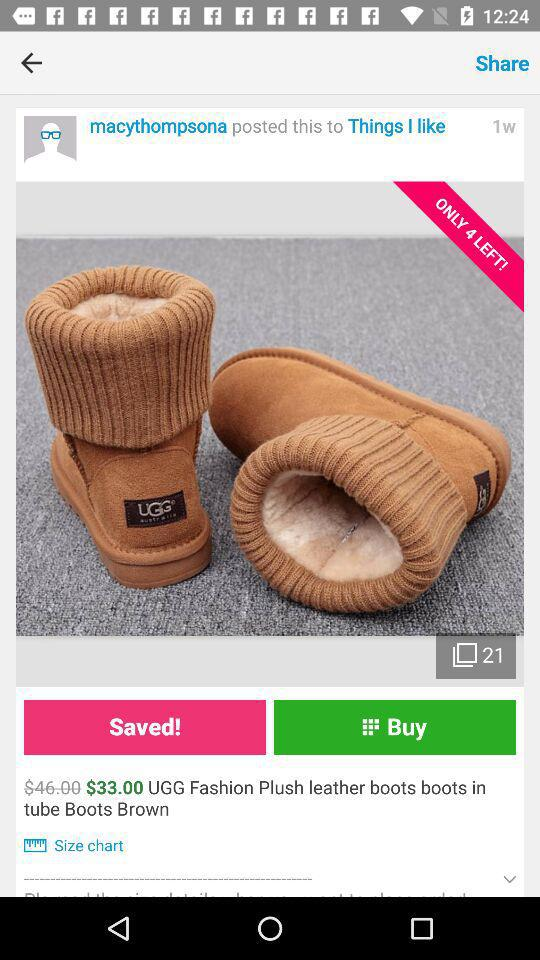How many boots are left for sale? There are only 4 boots left. 